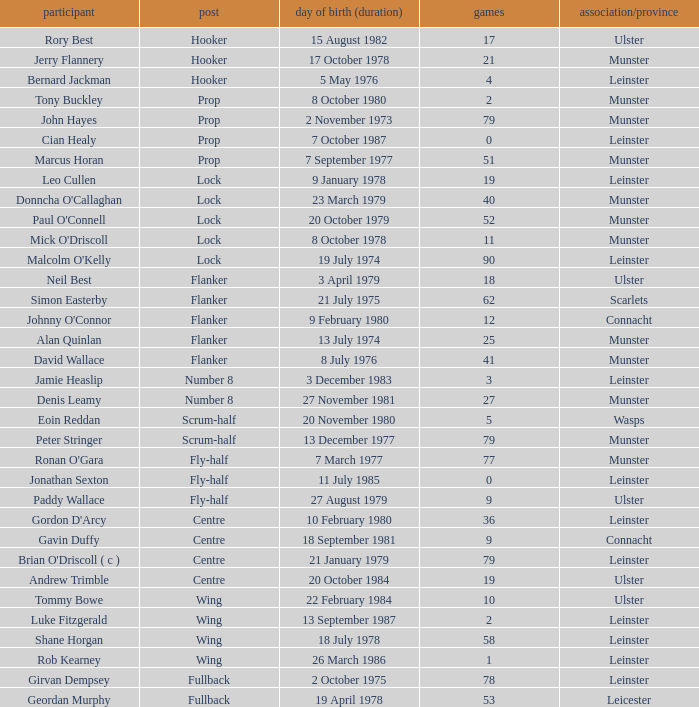Paddy Wallace who plays the position of fly-half has how many Caps? 9.0. 